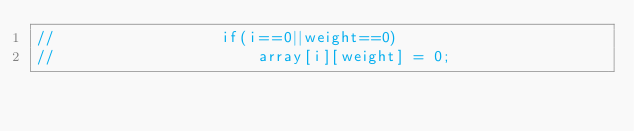<code> <loc_0><loc_0><loc_500><loc_500><_C++_>//					if(i==0||weight==0)
//						array[i][weight] = 0;</code> 